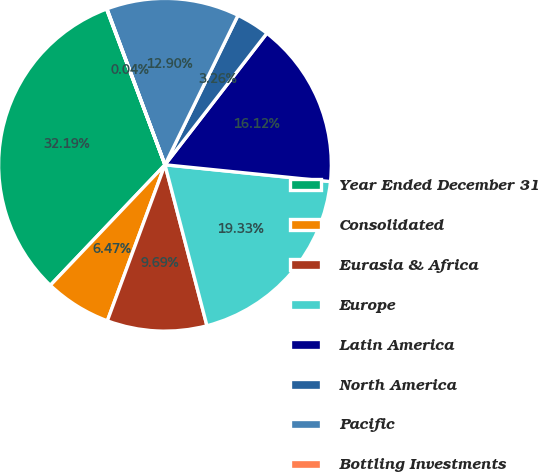<chart> <loc_0><loc_0><loc_500><loc_500><pie_chart><fcel>Year Ended December 31<fcel>Consolidated<fcel>Eurasia & Africa<fcel>Europe<fcel>Latin America<fcel>North America<fcel>Pacific<fcel>Bottling Investments<nl><fcel>32.19%<fcel>6.47%<fcel>9.69%<fcel>19.33%<fcel>16.12%<fcel>3.26%<fcel>12.9%<fcel>0.04%<nl></chart> 